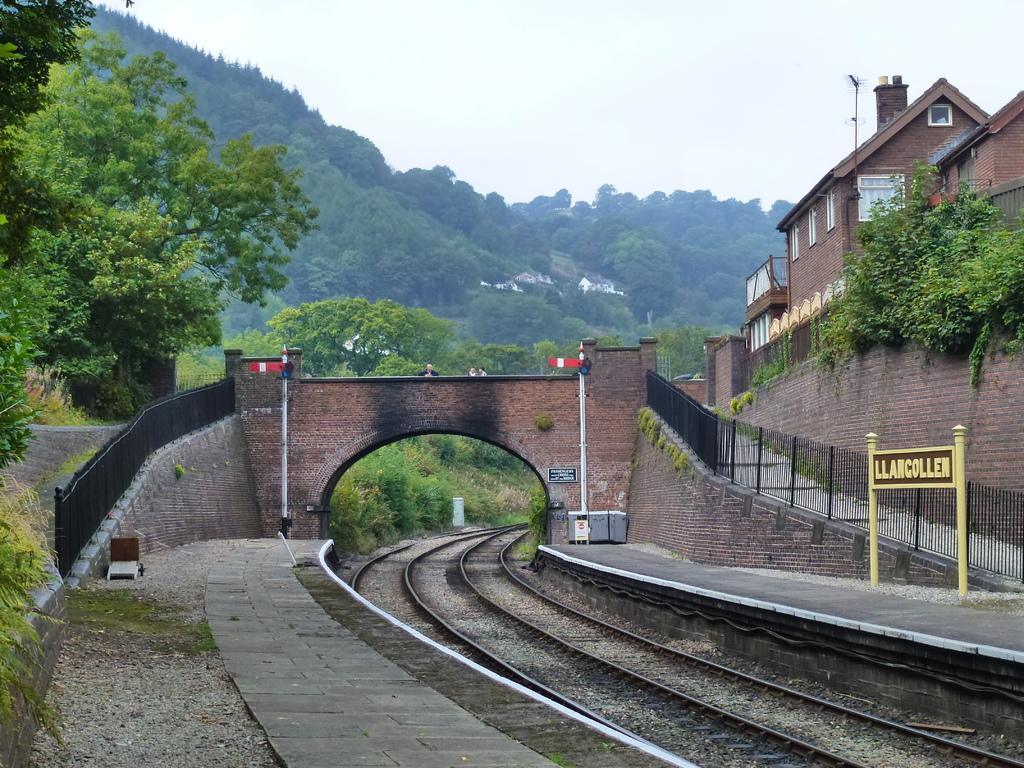What does the sign say upon the yellow posts?
Keep it short and to the point. Llancollen. 